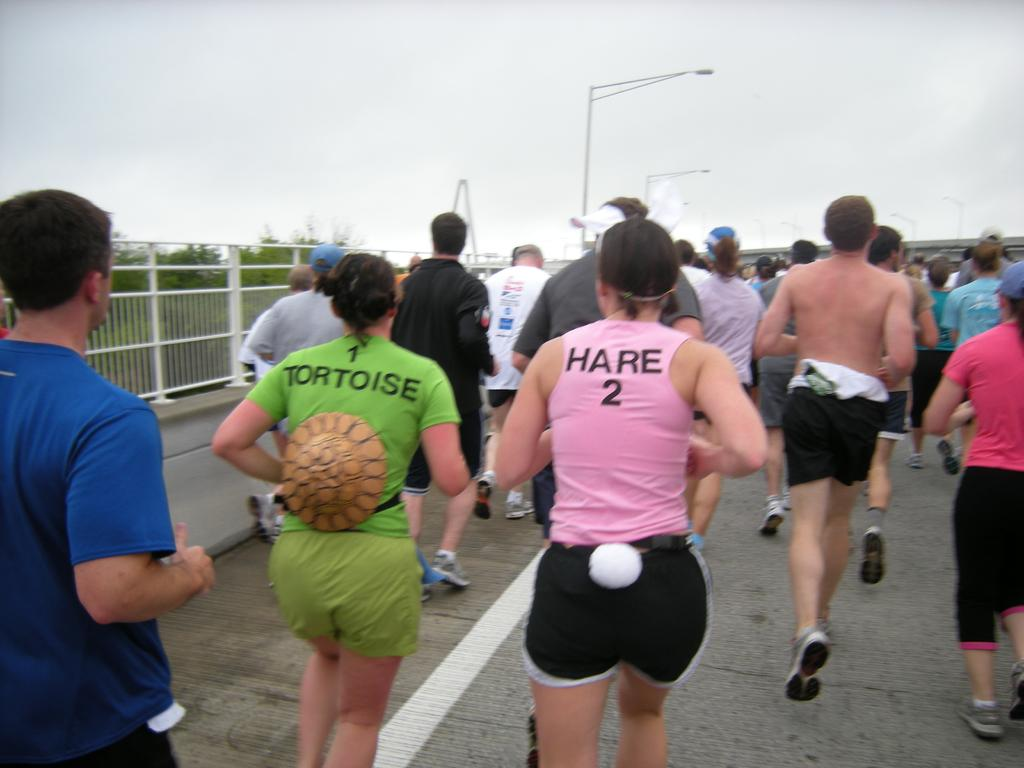What are the people in the image doing? The people in the image are running on the road. What can be seen alongside the road in the image? There is a fencing and trees visible in the image. What structures are present in the image for providing light? Light poles are visible in the image. What is visible in the background of the image? The sky is visible in the image. What type of tax is being collected from the people running in the image? There is no mention of tax collection in the image; people are simply running on the road. 